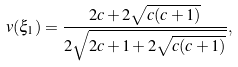<formula> <loc_0><loc_0><loc_500><loc_500>v ( \xi _ { 1 } ) = \frac { 2 c + 2 \sqrt { c ( c + 1 ) } } { 2 \sqrt { 2 c + 1 + 2 \sqrt { c ( c + 1 ) } } } ,</formula> 